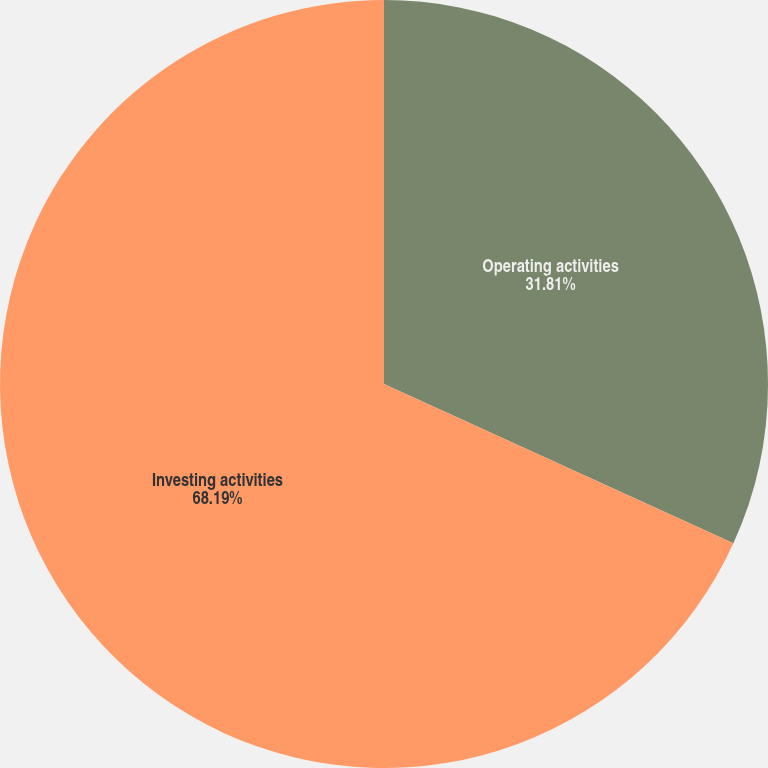Convert chart. <chart><loc_0><loc_0><loc_500><loc_500><pie_chart><fcel>Operating activities<fcel>Investing activities<nl><fcel>31.81%<fcel>68.19%<nl></chart> 